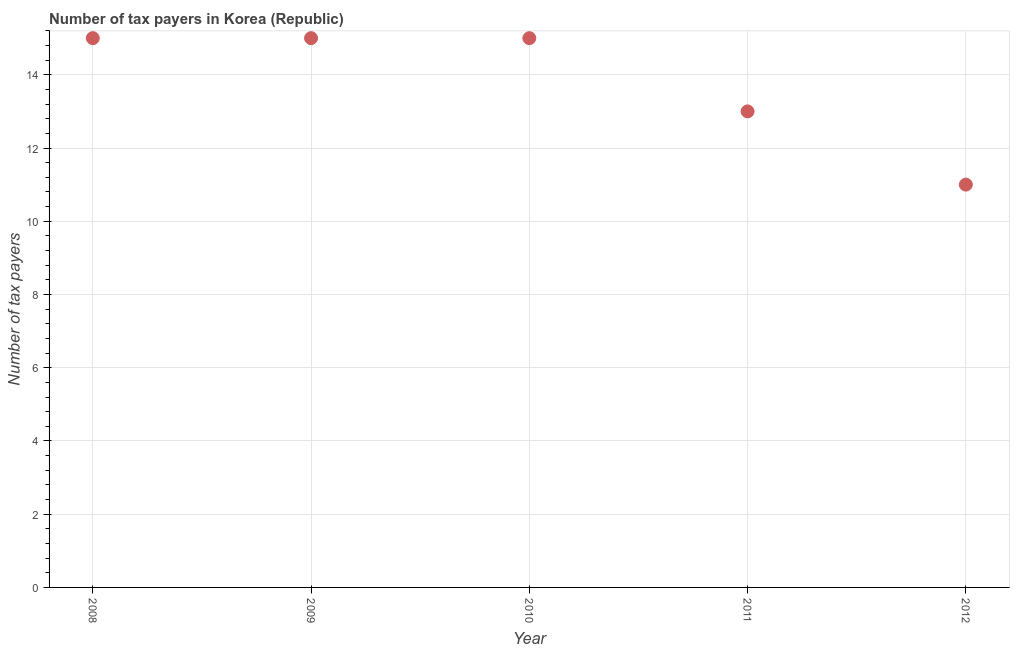What is the number of tax payers in 2012?
Provide a short and direct response. 11. Across all years, what is the maximum number of tax payers?
Give a very brief answer. 15. Across all years, what is the minimum number of tax payers?
Provide a succinct answer. 11. What is the sum of the number of tax payers?
Keep it short and to the point. 69. What is the difference between the number of tax payers in 2008 and 2012?
Your response must be concise. 4. What is the median number of tax payers?
Give a very brief answer. 15. What is the ratio of the number of tax payers in 2011 to that in 2012?
Make the answer very short. 1.18. What is the difference between the highest and the second highest number of tax payers?
Your answer should be compact. 0. Is the sum of the number of tax payers in 2008 and 2010 greater than the maximum number of tax payers across all years?
Ensure brevity in your answer.  Yes. What is the difference between the highest and the lowest number of tax payers?
Make the answer very short. 4. What is the difference between two consecutive major ticks on the Y-axis?
Offer a very short reply. 2. Are the values on the major ticks of Y-axis written in scientific E-notation?
Provide a short and direct response. No. Does the graph contain grids?
Provide a succinct answer. Yes. What is the title of the graph?
Provide a short and direct response. Number of tax payers in Korea (Republic). What is the label or title of the X-axis?
Offer a terse response. Year. What is the label or title of the Y-axis?
Your answer should be compact. Number of tax payers. What is the Number of tax payers in 2010?
Make the answer very short. 15. What is the Number of tax payers in 2011?
Offer a terse response. 13. What is the difference between the Number of tax payers in 2008 and 2009?
Your response must be concise. 0. What is the difference between the Number of tax payers in 2008 and 2011?
Ensure brevity in your answer.  2. What is the difference between the Number of tax payers in 2009 and 2011?
Your answer should be very brief. 2. What is the difference between the Number of tax payers in 2009 and 2012?
Provide a short and direct response. 4. What is the difference between the Number of tax payers in 2010 and 2012?
Give a very brief answer. 4. What is the difference between the Number of tax payers in 2011 and 2012?
Offer a terse response. 2. What is the ratio of the Number of tax payers in 2008 to that in 2010?
Provide a short and direct response. 1. What is the ratio of the Number of tax payers in 2008 to that in 2011?
Ensure brevity in your answer.  1.15. What is the ratio of the Number of tax payers in 2008 to that in 2012?
Offer a very short reply. 1.36. What is the ratio of the Number of tax payers in 2009 to that in 2011?
Give a very brief answer. 1.15. What is the ratio of the Number of tax payers in 2009 to that in 2012?
Your response must be concise. 1.36. What is the ratio of the Number of tax payers in 2010 to that in 2011?
Your response must be concise. 1.15. What is the ratio of the Number of tax payers in 2010 to that in 2012?
Your answer should be very brief. 1.36. What is the ratio of the Number of tax payers in 2011 to that in 2012?
Provide a succinct answer. 1.18. 